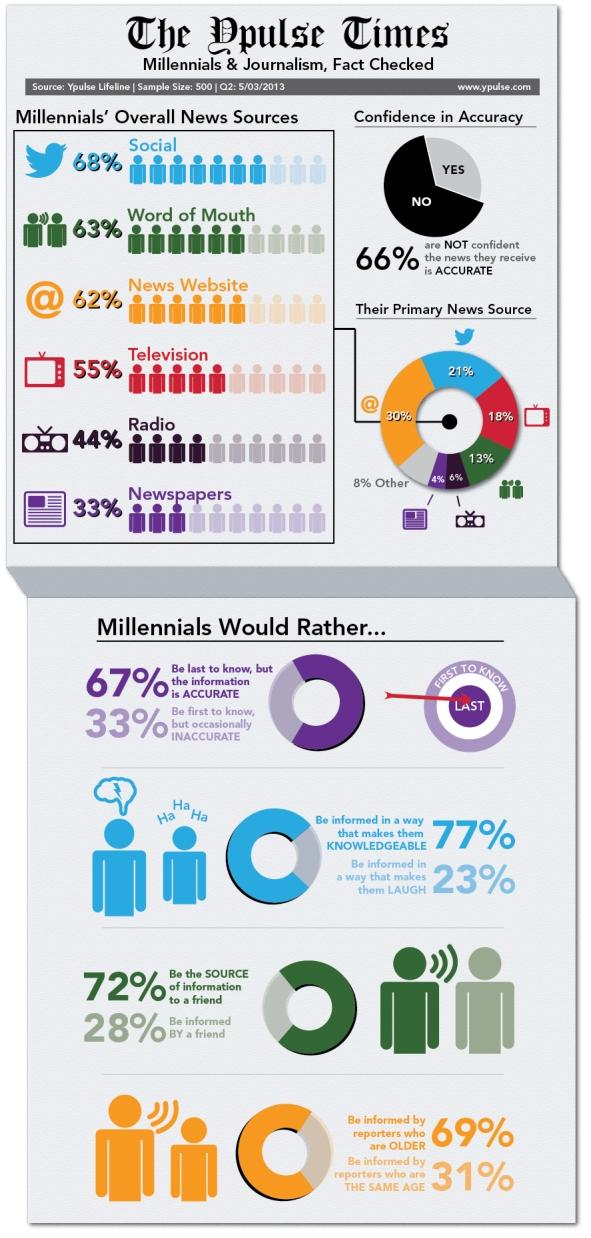Give some essential details in this illustration. According to research, the majority of millennials prefer accurate information over inaccurate or funny content. They value knowledge over entertainment. According to a recent survey, 21% of millennials rely on social networks as their primary source of news. According to a recent survey, 18% of millennials rely on television as their primary source of news. According to a recent survey, 30% of millennials reported that they use a news website as their primary source of news. 